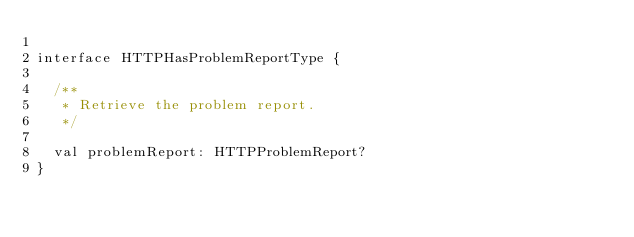<code> <loc_0><loc_0><loc_500><loc_500><_Kotlin_>
interface HTTPHasProblemReportType {

  /**
   * Retrieve the problem report.
   */

  val problemReport: HTTPProblemReport?
}
</code> 